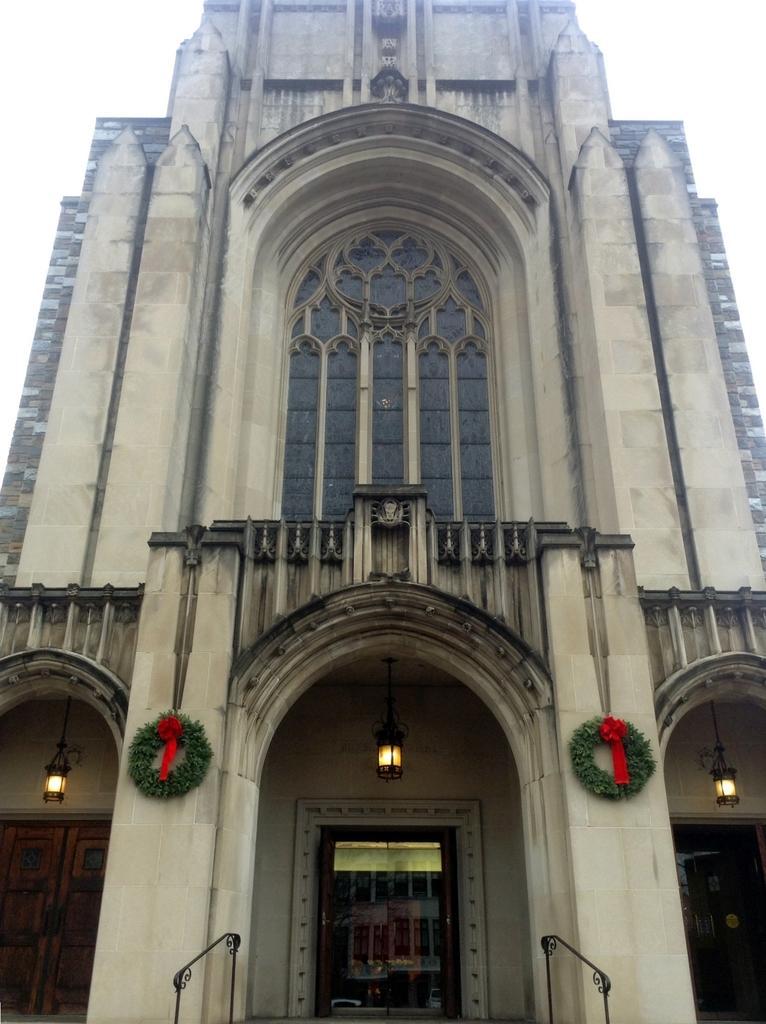Could you give a brief overview of what you see in this image? In this image I can see building and lights visible in the building 